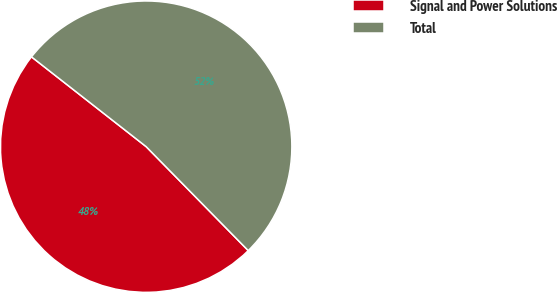Convert chart to OTSL. <chart><loc_0><loc_0><loc_500><loc_500><pie_chart><fcel>Signal and Power Solutions<fcel>Total<nl><fcel>47.93%<fcel>52.07%<nl></chart> 